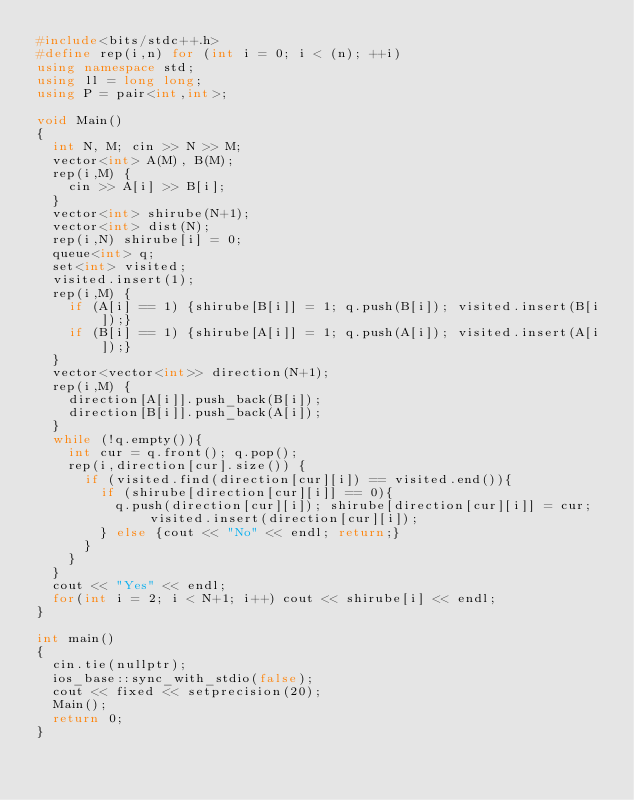<code> <loc_0><loc_0><loc_500><loc_500><_C++_>#include<bits/stdc++.h>
#define rep(i,n) for (int i = 0; i < (n); ++i)
using namespace std;
using ll = long long;
using P = pair<int,int>;

void Main()
{
  int N, M; cin >> N >> M;
  vector<int> A(M), B(M);
  rep(i,M) {
    cin >> A[i] >> B[i];
  }
  vector<int> shirube(N+1);
  vector<int> dist(N);
  rep(i,N) shirube[i] = 0;
  queue<int> q;
  set<int> visited;
  visited.insert(1);
  rep(i,M) {
    if (A[i] == 1) {shirube[B[i]] = 1; q.push(B[i]); visited.insert(B[i]);}
    if (B[i] == 1) {shirube[A[i]] = 1; q.push(A[i]); visited.insert(A[i]);}
  }
  vector<vector<int>> direction(N+1);
  rep(i,M) {
    direction[A[i]].push_back(B[i]);
    direction[B[i]].push_back(A[i]);
  }
  while (!q.empty()){
  	int cur = q.front(); q.pop();
    rep(i,direction[cur].size()) {
      if (visited.find(direction[cur][i]) == visited.end()){
        if (shirube[direction[cur][i]] == 0){
          q.push(direction[cur][i]); shirube[direction[cur][i]] = cur; visited.insert(direction[cur][i]);
        } else {cout << "No" << endl; return;}
      }
    }
  }
  cout << "Yes" << endl;
  for(int i = 2; i < N+1; i++) cout << shirube[i] << endl;
}

int main()
{
  cin.tie(nullptr);
  ios_base::sync_with_stdio(false);
  cout << fixed << setprecision(20);
  Main();
  return 0;
}</code> 